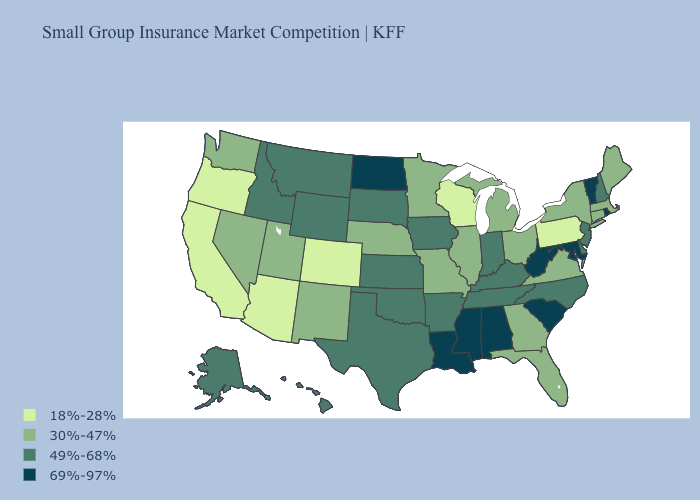Which states have the highest value in the USA?
Short answer required. Alabama, Louisiana, Maryland, Mississippi, North Dakota, Rhode Island, South Carolina, Vermont, West Virginia. Does Delaware have a higher value than New Jersey?
Concise answer only. No. What is the lowest value in states that border Montana?
Write a very short answer. 49%-68%. Name the states that have a value in the range 18%-28%?
Write a very short answer. Arizona, California, Colorado, Oregon, Pennsylvania, Wisconsin. Does Vermont have the same value as Alabama?
Quick response, please. Yes. Among the states that border Florida , does Alabama have the highest value?
Keep it brief. Yes. Does Wyoming have the highest value in the West?
Short answer required. Yes. What is the value of North Dakota?
Concise answer only. 69%-97%. Does New Hampshire have a lower value than Mississippi?
Be succinct. Yes. Does Illinois have a higher value than Utah?
Write a very short answer. No. Among the states that border New Hampshire , does Vermont have the lowest value?
Keep it brief. No. What is the lowest value in states that border Maryland?
Concise answer only. 18%-28%. Does Connecticut have the same value as Louisiana?
Keep it brief. No. Name the states that have a value in the range 49%-68%?
Quick response, please. Alaska, Arkansas, Delaware, Hawaii, Idaho, Indiana, Iowa, Kansas, Kentucky, Montana, New Hampshire, New Jersey, North Carolina, Oklahoma, South Dakota, Tennessee, Texas, Wyoming. 